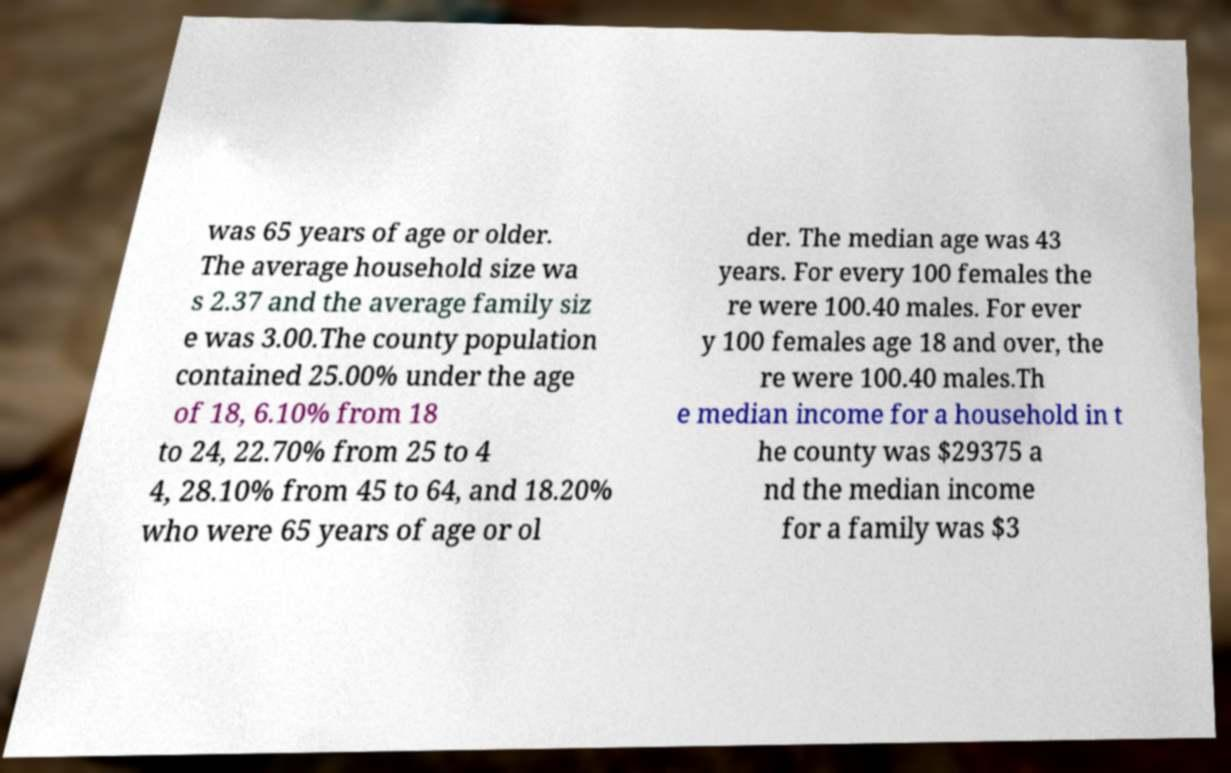What messages or text are displayed in this image? I need them in a readable, typed format. was 65 years of age or older. The average household size wa s 2.37 and the average family siz e was 3.00.The county population contained 25.00% under the age of 18, 6.10% from 18 to 24, 22.70% from 25 to 4 4, 28.10% from 45 to 64, and 18.20% who were 65 years of age or ol der. The median age was 43 years. For every 100 females the re were 100.40 males. For ever y 100 females age 18 and over, the re were 100.40 males.Th e median income for a household in t he county was $29375 a nd the median income for a family was $3 